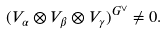Convert formula to latex. <formula><loc_0><loc_0><loc_500><loc_500>( V _ { \alpha } \otimes V _ { \beta } \otimes V _ { \gamma } ) ^ { G ^ { \vee } } \neq 0 .</formula> 